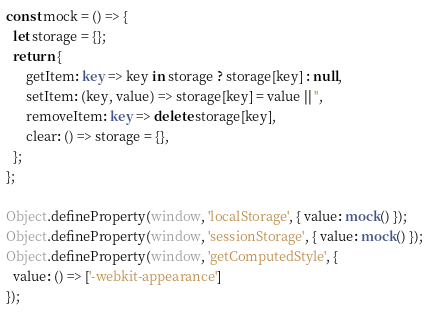<code> <loc_0><loc_0><loc_500><loc_500><_TypeScript_>const mock = () => {
  let storage = {};
  return {
      getItem: key => key in storage ? storage[key] : null,
      setItem: (key, value) => storage[key] = value || '',
      removeItem: key => delete storage[key],
      clear: () => storage = {},
  };
};

Object.defineProperty(window, 'localStorage', { value: mock() });
Object.defineProperty(window, 'sessionStorage', { value: mock() });
Object.defineProperty(window, 'getComputedStyle', {
  value: () => ['-webkit-appearance']
});
</code> 